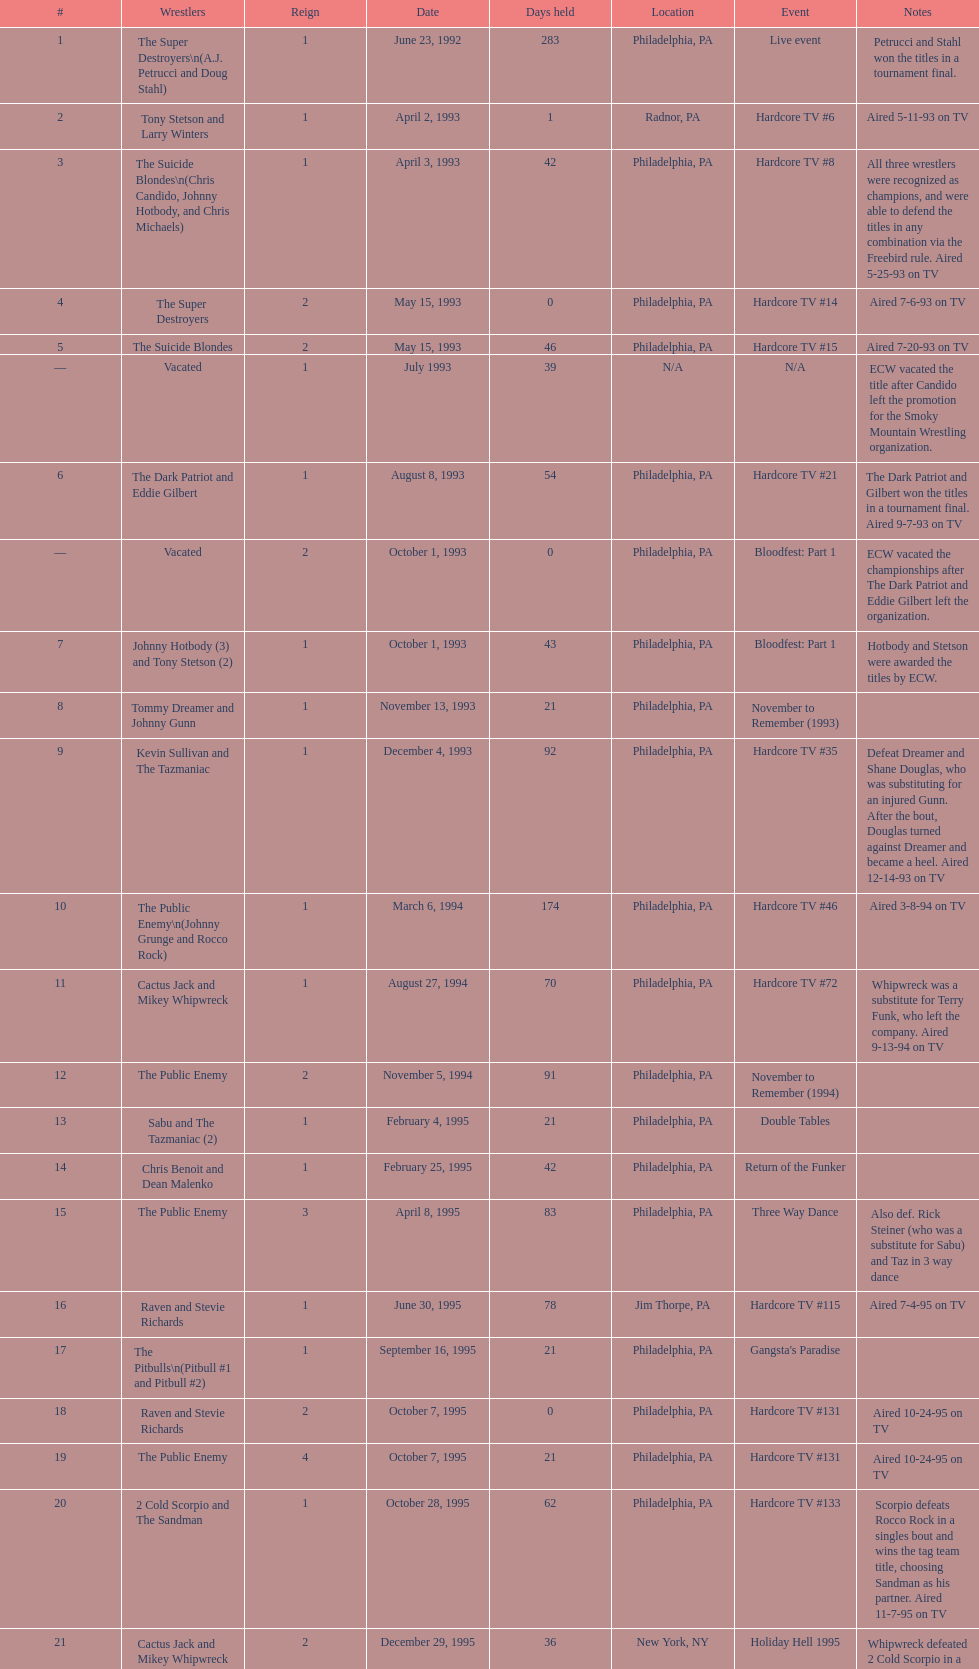Which was the only squad to triumph by forfeit? The Dudley Boyz. Can you give me this table as a dict? {'header': ['#', 'Wrestlers', 'Reign', 'Date', 'Days held', 'Location', 'Event', 'Notes'], 'rows': [['1', 'The Super Destroyers\\n(A.J. Petrucci and Doug Stahl)', '1', 'June 23, 1992', '283', 'Philadelphia, PA', 'Live event', 'Petrucci and Stahl won the titles in a tournament final.'], ['2', 'Tony Stetson and Larry Winters', '1', 'April 2, 1993', '1', 'Radnor, PA', 'Hardcore TV #6', 'Aired 5-11-93 on TV'], ['3', 'The Suicide Blondes\\n(Chris Candido, Johnny Hotbody, and Chris Michaels)', '1', 'April 3, 1993', '42', 'Philadelphia, PA', 'Hardcore TV #8', 'All three wrestlers were recognized as champions, and were able to defend the titles in any combination via the Freebird rule. Aired 5-25-93 on TV'], ['4', 'The Super Destroyers', '2', 'May 15, 1993', '0', 'Philadelphia, PA', 'Hardcore TV #14', 'Aired 7-6-93 on TV'], ['5', 'The Suicide Blondes', '2', 'May 15, 1993', '46', 'Philadelphia, PA', 'Hardcore TV #15', 'Aired 7-20-93 on TV'], ['—', 'Vacated', '1', 'July 1993', '39', 'N/A', 'N/A', 'ECW vacated the title after Candido left the promotion for the Smoky Mountain Wrestling organization.'], ['6', 'The Dark Patriot and Eddie Gilbert', '1', 'August 8, 1993', '54', 'Philadelphia, PA', 'Hardcore TV #21', 'The Dark Patriot and Gilbert won the titles in a tournament final. Aired 9-7-93 on TV'], ['—', 'Vacated', '2', 'October 1, 1993', '0', 'Philadelphia, PA', 'Bloodfest: Part 1', 'ECW vacated the championships after The Dark Patriot and Eddie Gilbert left the organization.'], ['7', 'Johnny Hotbody (3) and Tony Stetson (2)', '1', 'October 1, 1993', '43', 'Philadelphia, PA', 'Bloodfest: Part 1', 'Hotbody and Stetson were awarded the titles by ECW.'], ['8', 'Tommy Dreamer and Johnny Gunn', '1', 'November 13, 1993', '21', 'Philadelphia, PA', 'November to Remember (1993)', ''], ['9', 'Kevin Sullivan and The Tazmaniac', '1', 'December 4, 1993', '92', 'Philadelphia, PA', 'Hardcore TV #35', 'Defeat Dreamer and Shane Douglas, who was substituting for an injured Gunn. After the bout, Douglas turned against Dreamer and became a heel. Aired 12-14-93 on TV'], ['10', 'The Public Enemy\\n(Johnny Grunge and Rocco Rock)', '1', 'March 6, 1994', '174', 'Philadelphia, PA', 'Hardcore TV #46', 'Aired 3-8-94 on TV'], ['11', 'Cactus Jack and Mikey Whipwreck', '1', 'August 27, 1994', '70', 'Philadelphia, PA', 'Hardcore TV #72', 'Whipwreck was a substitute for Terry Funk, who left the company. Aired 9-13-94 on TV'], ['12', 'The Public Enemy', '2', 'November 5, 1994', '91', 'Philadelphia, PA', 'November to Remember (1994)', ''], ['13', 'Sabu and The Tazmaniac (2)', '1', 'February 4, 1995', '21', 'Philadelphia, PA', 'Double Tables', ''], ['14', 'Chris Benoit and Dean Malenko', '1', 'February 25, 1995', '42', 'Philadelphia, PA', 'Return of the Funker', ''], ['15', 'The Public Enemy', '3', 'April 8, 1995', '83', 'Philadelphia, PA', 'Three Way Dance', 'Also def. Rick Steiner (who was a substitute for Sabu) and Taz in 3 way dance'], ['16', 'Raven and Stevie Richards', '1', 'June 30, 1995', '78', 'Jim Thorpe, PA', 'Hardcore TV #115', 'Aired 7-4-95 on TV'], ['17', 'The Pitbulls\\n(Pitbull #1 and Pitbull #2)', '1', 'September 16, 1995', '21', 'Philadelphia, PA', "Gangsta's Paradise", ''], ['18', 'Raven and Stevie Richards', '2', 'October 7, 1995', '0', 'Philadelphia, PA', 'Hardcore TV #131', 'Aired 10-24-95 on TV'], ['19', 'The Public Enemy', '4', 'October 7, 1995', '21', 'Philadelphia, PA', 'Hardcore TV #131', 'Aired 10-24-95 on TV'], ['20', '2 Cold Scorpio and The Sandman', '1', 'October 28, 1995', '62', 'Philadelphia, PA', 'Hardcore TV #133', 'Scorpio defeats Rocco Rock in a singles bout and wins the tag team title, choosing Sandman as his partner. Aired 11-7-95 on TV'], ['21', 'Cactus Jack and Mikey Whipwreck', '2', 'December 29, 1995', '36', 'New York, NY', 'Holiday Hell 1995', "Whipwreck defeated 2 Cold Scorpio in a singles match to win both the tag team titles and the ECW World Television Championship; Cactus Jack came out and declared himself to be Mikey's partner after he won the match."], ['22', 'The Eliminators\\n(Kronus and Saturn)', '1', 'February 3, 1996', '182', 'New York, NY', 'Big Apple Blizzard Blast', ''], ['23', 'The Gangstas\\n(Mustapha Saed and New Jack)', '1', 'August 3, 1996', '139', 'Philadelphia, PA', 'Doctor Is In', ''], ['24', 'The Eliminators', '2', 'December 20, 1996', '85', 'Middletown, NY', 'Hardcore TV #193', 'Aired on 12/31/96 on Hardcore TV'], ['25', 'The Dudley Boyz\\n(Buh Buh Ray Dudley and D-Von Dudley)', '1', 'March 15, 1997', '29', 'Philadelphia, PA', 'Hostile City Showdown', 'Aired 3/20/97 on Hardcore TV'], ['26', 'The Eliminators', '3', 'April 13, 1997', '68', 'Philadelphia, PA', 'Barely Legal', ''], ['27', 'The Dudley Boyz', '2', 'June 20, 1997', '29', 'Waltham, MA', 'Hardcore TV #218', 'The Dudley Boyz defeated Kronus in a handicap match as a result of a sidelining injury sustained by Saturn. Aired 6-26-97 on TV'], ['28', 'The Gangstas', '2', 'July 19, 1997', '29', 'Philadelphia, PA', 'Heat Wave 1997/Hardcore TV #222', 'Aired 7-24-97 on TV'], ['29', 'The Dudley Boyz', '3', 'August 17, 1997', '95', 'Fort Lauderdale, FL', 'Hardcore Heaven (1997)', 'The Dudley Boyz won the championship via forfeit as a result of Mustapha Saed leaving the promotion before Hardcore Heaven took place.'], ['30', 'The Gangstanators\\n(Kronus (4) and New Jack (3))', '1', 'September 20, 1997', '28', 'Philadelphia, PA', 'As Good as it Gets', 'Aired 9-27-97 on TV'], ['31', 'Full Blooded Italians\\n(Little Guido and Tracy Smothers)', '1', 'October 18, 1997', '48', 'Philadelphia, PA', 'Hardcore TV #236', 'Aired 11-1-97 on TV'], ['32', 'Doug Furnas and Phil LaFon', '1', 'December 5, 1997', '1', 'Waltham, MA', 'Live event', ''], ['33', 'Chris Candido (3) and Lance Storm', '1', 'December 6, 1997', '203', 'Philadelphia, PA', 'Better than Ever', ''], ['34', 'Sabu (2) and Rob Van Dam', '1', 'June 27, 1998', '119', 'Philadelphia, PA', 'Hardcore TV #271', 'Aired 7-1-98 on TV'], ['35', 'The Dudley Boyz', '4', 'October 24, 1998', '8', 'Cleveland, OH', 'Hardcore TV #288', 'Aired 10-28-98 on TV'], ['36', 'Balls Mahoney and Masato Tanaka', '1', 'November 1, 1998', '5', 'New Orleans, LA', 'November to Remember (1998)', ''], ['37', 'The Dudley Boyz', '5', 'November 6, 1998', '37', 'New York, NY', 'Hardcore TV #290', 'Aired 11-11-98 on TV'], ['38', 'Sabu (3) and Rob Van Dam', '2', 'December 13, 1998', '125', 'Tokyo, Japan', 'ECW/FMW Supershow II', 'Aired 12-16-98 on TV'], ['39', 'The Dudley Boyz', '6', 'April 17, 1999', '92', 'Buffalo, NY', 'Hardcore TV #313', 'D-Von Dudley defeated Van Dam in a singles match to win the championship for his team. Aired 4-23-99 on TV'], ['40', 'Spike Dudley and Balls Mahoney (2)', '1', 'July 18, 1999', '26', 'Dayton, OH', 'Heat Wave (1999)', ''], ['41', 'The Dudley Boyz', '7', 'August 13, 1999', '1', 'Cleveland, OH', 'Hardcore TV #330', 'Aired 8-20-99 on TV'], ['42', 'Spike Dudley and Balls Mahoney (3)', '2', 'August 14, 1999', '12', 'Toledo, OH', 'Hardcore TV #331', 'Aired 8-27-99 on TV'], ['43', 'The Dudley Boyz', '8', 'August 26, 1999', '0', 'New York, NY', 'ECW on TNN#2', 'Aired 9-3-99 on TV'], ['44', 'Tommy Dreamer (2) and Raven (3)', '1', 'August 26, 1999', '136', 'New York, NY', 'ECW on TNN#2', 'Aired 9-3-99 on TV'], ['45', 'Impact Players\\n(Justin Credible and Lance Storm (2))', '1', 'January 9, 2000', '48', 'Birmingham, AL', 'Guilty as Charged (2000)', ''], ['46', 'Tommy Dreamer (3) and Masato Tanaka (2)', '1', 'February 26, 2000', '7', 'Cincinnati, OH', 'Hardcore TV #358', 'Aired 3-7-00 on TV'], ['47', 'Mike Awesome and Raven (4)', '1', 'March 4, 2000', '8', 'Philadelphia, PA', 'ECW on TNN#29', 'Aired 3-10-00 on TV'], ['48', 'Impact Players\\n(Justin Credible and Lance Storm (3))', '2', 'March 12, 2000', '31', 'Danbury, CT', 'Living Dangerously', ''], ['—', 'Vacated', '3', 'April 22, 2000', '125', 'Philadelphia, PA', 'Live event', 'At CyberSlam, Justin Credible threw down the titles to become eligible for the ECW World Heavyweight Championship. Storm later left for World Championship Wrestling. As a result of the circumstances, Credible vacated the championship.'], ['49', 'Yoshihiro Tajiri and Mikey Whipwreck (3)', '1', 'August 25, 2000', '1', 'New York, NY', 'ECW on TNN#55', 'Aired 9-1-00 on TV'], ['50', 'Full Blooded Italians\\n(Little Guido (2) and Tony Mamaluke)', '1', 'August 26, 2000', '99', 'New York, NY', 'ECW on TNN#56', 'Aired 9-8-00 on TV'], ['51', 'Danny Doring and Roadkill', '1', 'December 3, 2000', '122', 'New York, NY', 'Massacre on 34th Street', "Doring and Roadkill's reign was the final one in the title's history."]]} 